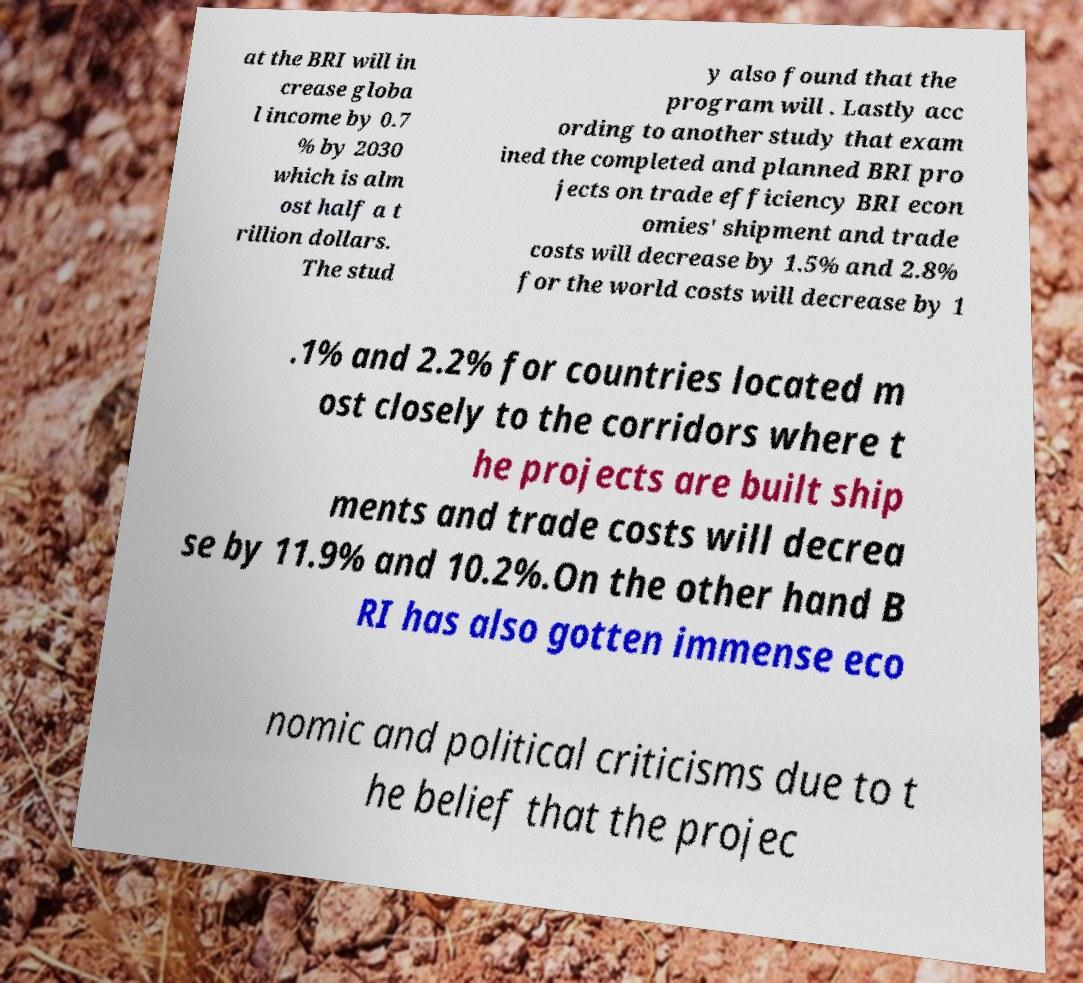Please identify and transcribe the text found in this image. at the BRI will in crease globa l income by 0.7 % by 2030 which is alm ost half a t rillion dollars. The stud y also found that the program will . Lastly acc ording to another study that exam ined the completed and planned BRI pro jects on trade efficiency BRI econ omies' shipment and trade costs will decrease by 1.5% and 2.8% for the world costs will decrease by 1 .1% and 2.2% for countries located m ost closely to the corridors where t he projects are built ship ments and trade costs will decrea se by 11.9% and 10.2%.On the other hand B RI has also gotten immense eco nomic and political criticisms due to t he belief that the projec 